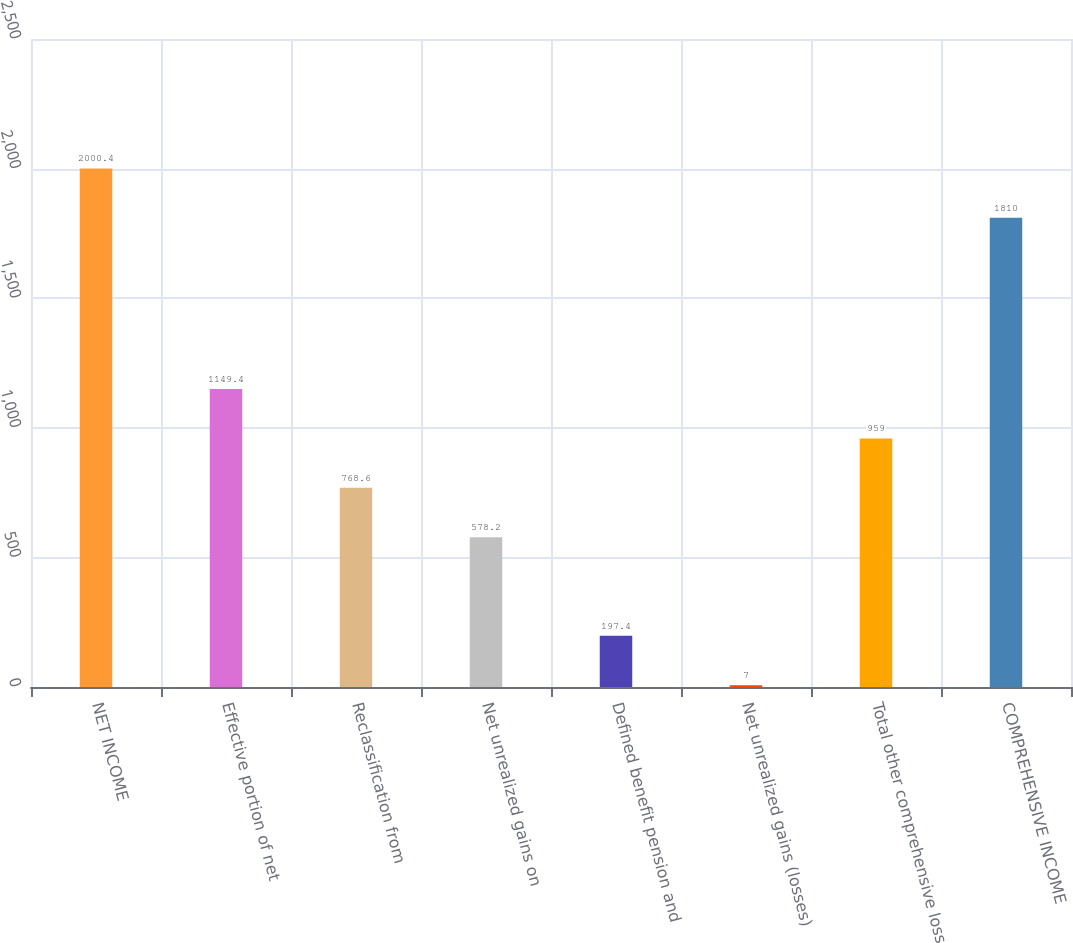Convert chart. <chart><loc_0><loc_0><loc_500><loc_500><bar_chart><fcel>NET INCOME<fcel>Effective portion of net<fcel>Reclassification from<fcel>Net unrealized gains on<fcel>Defined benefit pension and<fcel>Net unrealized gains (losses)<fcel>Total other comprehensive loss<fcel>COMPREHENSIVE INCOME<nl><fcel>2000.4<fcel>1149.4<fcel>768.6<fcel>578.2<fcel>197.4<fcel>7<fcel>959<fcel>1810<nl></chart> 